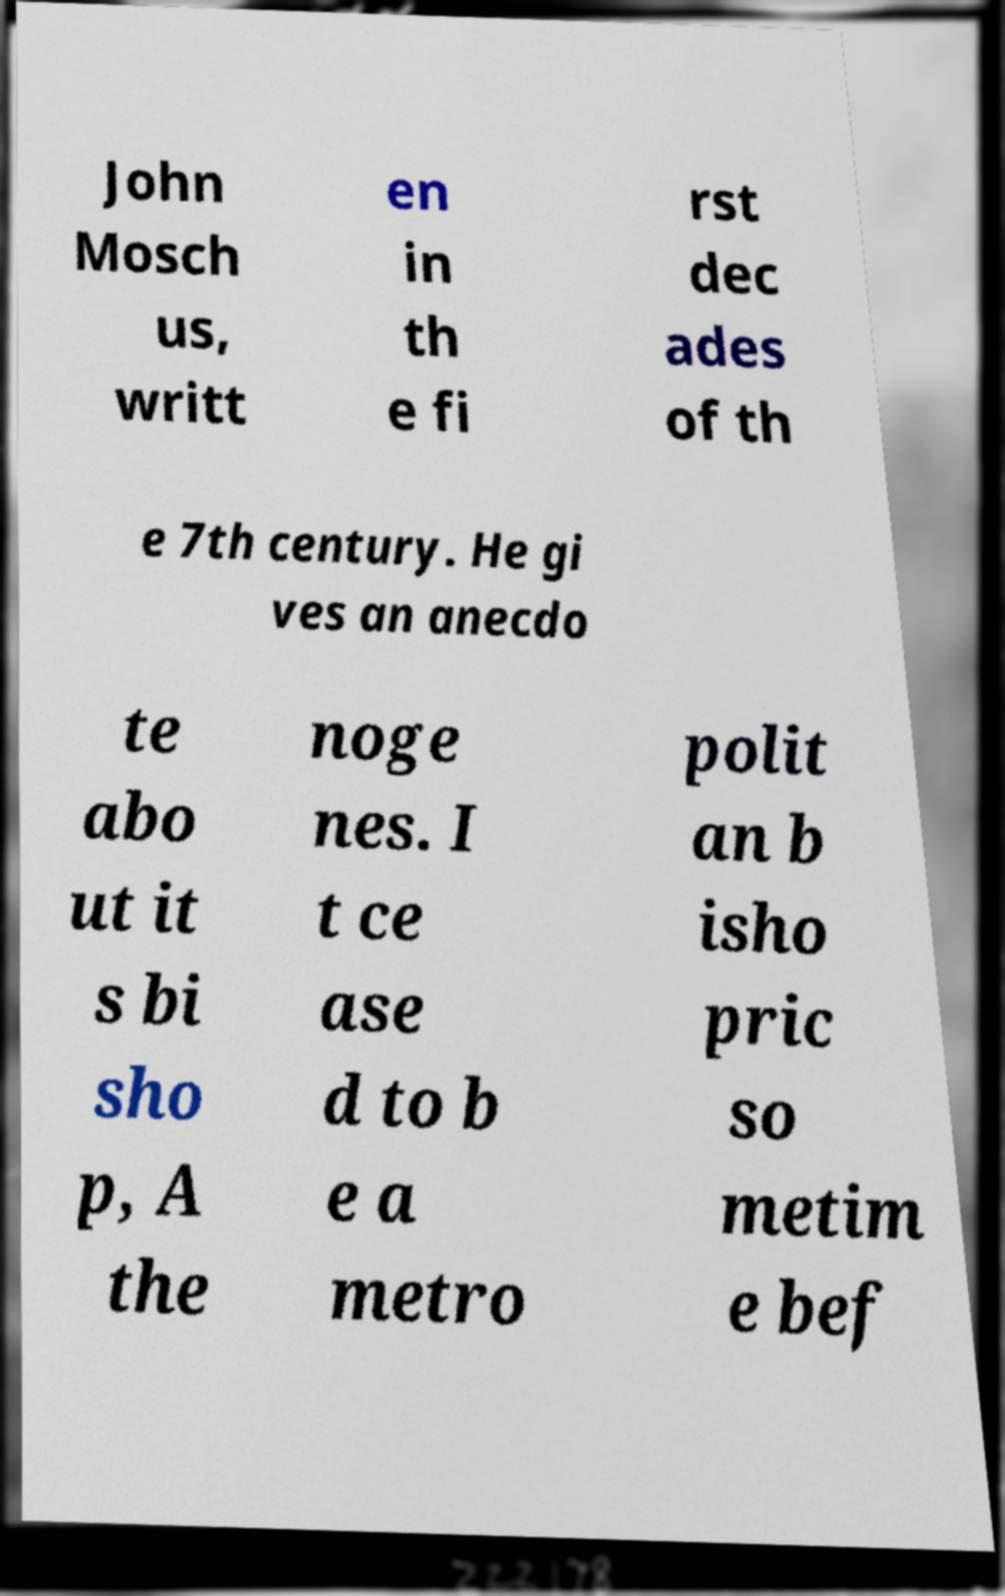I need the written content from this picture converted into text. Can you do that? John Mosch us, writt en in th e fi rst dec ades of th e 7th century. He gi ves an anecdo te abo ut it s bi sho p, A the noge nes. I t ce ase d to b e a metro polit an b isho pric so metim e bef 